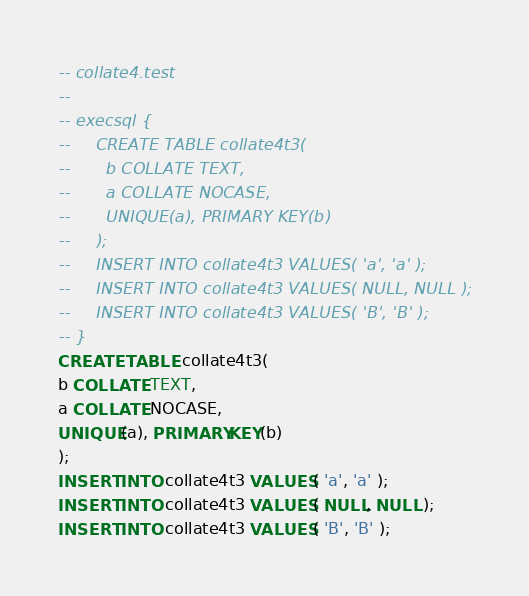<code> <loc_0><loc_0><loc_500><loc_500><_SQL_>-- collate4.test
-- 
-- execsql {
--     CREATE TABLE collate4t3(
--       b COLLATE TEXT,  
--       a COLLATE NOCASE, 
--       UNIQUE(a), PRIMARY KEY(b)
--     );
--     INSERT INTO collate4t3 VALUES( 'a', 'a' );
--     INSERT INTO collate4t3 VALUES( NULL, NULL );
--     INSERT INTO collate4t3 VALUES( 'B', 'B' );
-- }
CREATE TABLE collate4t3(
b COLLATE TEXT,  
a COLLATE NOCASE, 
UNIQUE(a), PRIMARY KEY(b)
);
INSERT INTO collate4t3 VALUES( 'a', 'a' );
INSERT INTO collate4t3 VALUES( NULL, NULL );
INSERT INTO collate4t3 VALUES( 'B', 'B' );</code> 